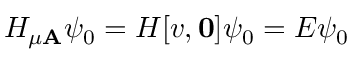Convert formula to latex. <formula><loc_0><loc_0><loc_500><loc_500>H _ { \mu A } \psi _ { 0 } = H [ v , 0 ] \psi _ { 0 } = E \psi _ { 0 }</formula> 